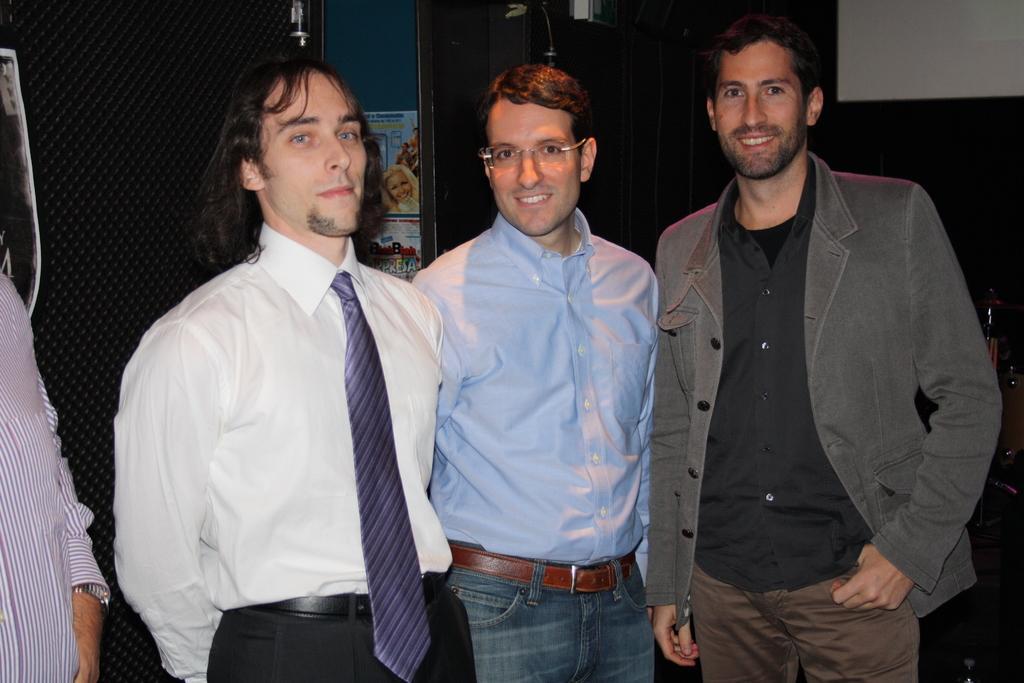Can you describe this image briefly? In the center of the picture there are three men with smiley faces. On the left there is a person. In the background there are some objects, calendar, poster and wall. 